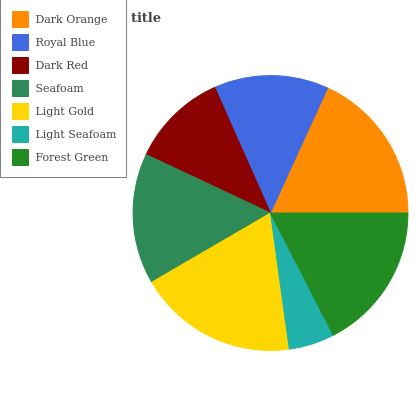Is Light Seafoam the minimum?
Answer yes or no. Yes. Is Light Gold the maximum?
Answer yes or no. Yes. Is Royal Blue the minimum?
Answer yes or no. No. Is Royal Blue the maximum?
Answer yes or no. No. Is Dark Orange greater than Royal Blue?
Answer yes or no. Yes. Is Royal Blue less than Dark Orange?
Answer yes or no. Yes. Is Royal Blue greater than Dark Orange?
Answer yes or no. No. Is Dark Orange less than Royal Blue?
Answer yes or no. No. Is Seafoam the high median?
Answer yes or no. Yes. Is Seafoam the low median?
Answer yes or no. Yes. Is Light Seafoam the high median?
Answer yes or no. No. Is Light Seafoam the low median?
Answer yes or no. No. 